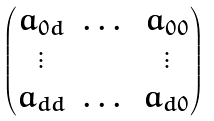<formula> <loc_0><loc_0><loc_500><loc_500>\begin{pmatrix} a _ { 0 d } & \dots & a _ { 0 0 } \\ \vdots & & \vdots \\ a _ { d d } & \dots & a _ { d 0 } \end{pmatrix}</formula> 